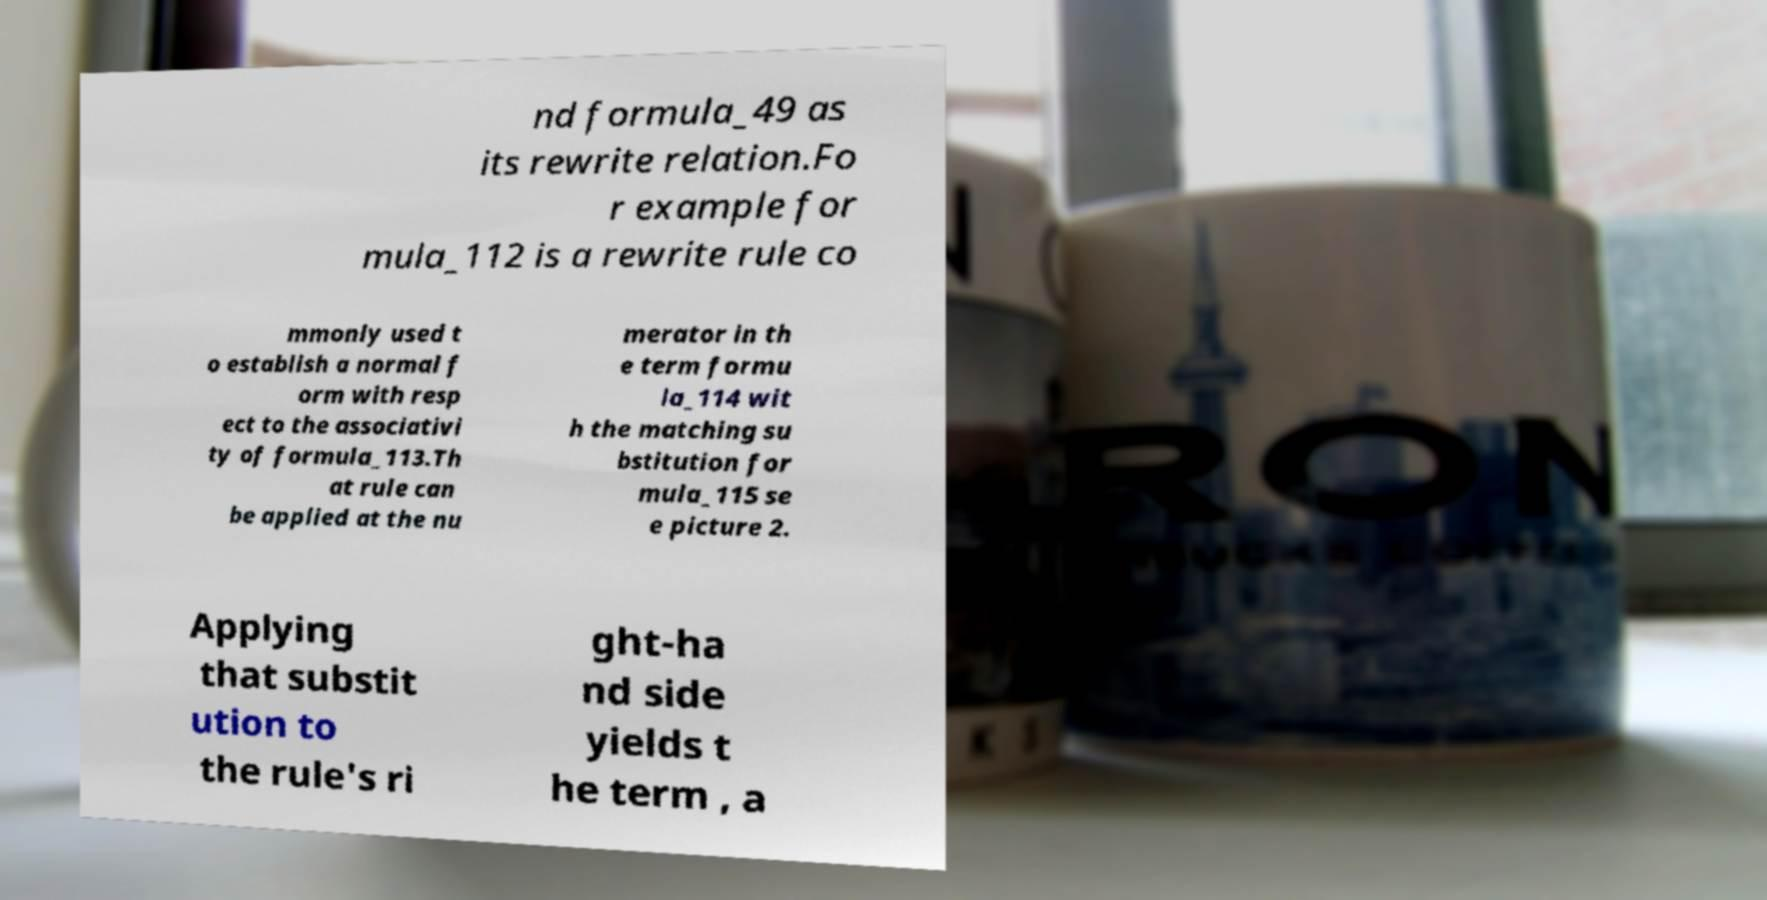For documentation purposes, I need the text within this image transcribed. Could you provide that? nd formula_49 as its rewrite relation.Fo r example for mula_112 is a rewrite rule co mmonly used t o establish a normal f orm with resp ect to the associativi ty of formula_113.Th at rule can be applied at the nu merator in th e term formu la_114 wit h the matching su bstitution for mula_115 se e picture 2. Applying that substit ution to the rule's ri ght-ha nd side yields t he term , a 